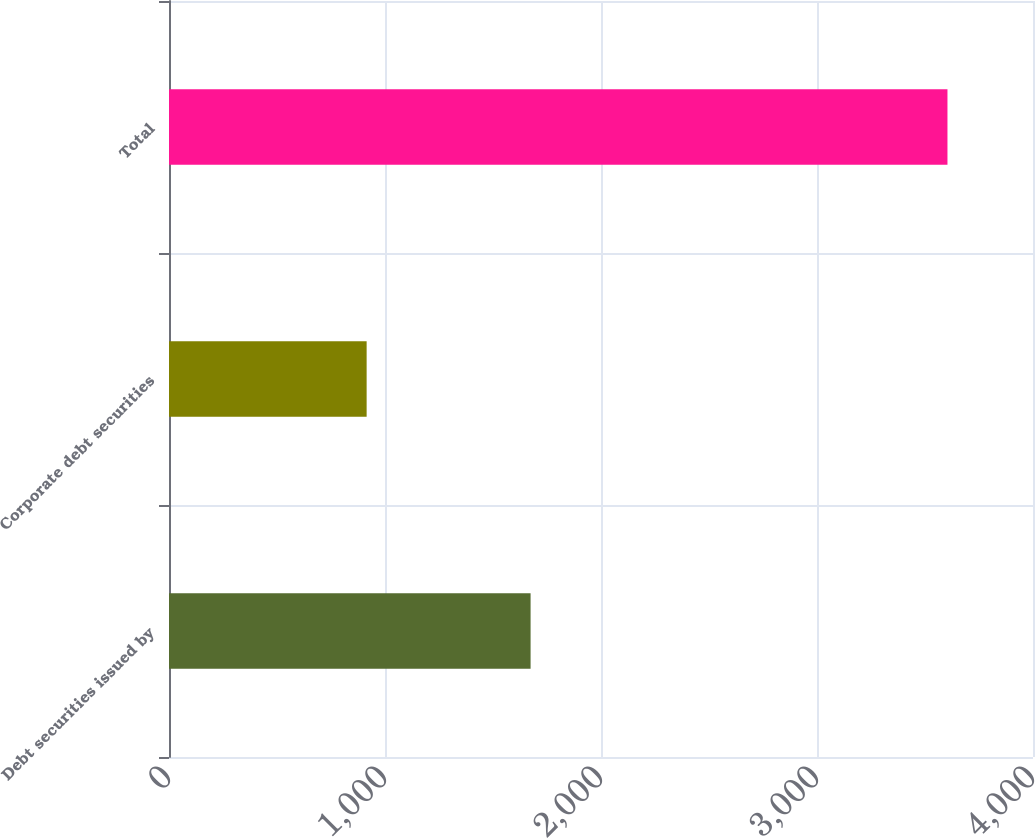Convert chart. <chart><loc_0><loc_0><loc_500><loc_500><bar_chart><fcel>Debt securities issued by<fcel>Corporate debt securities<fcel>Total<nl><fcel>1674<fcel>915<fcel>3604<nl></chart> 